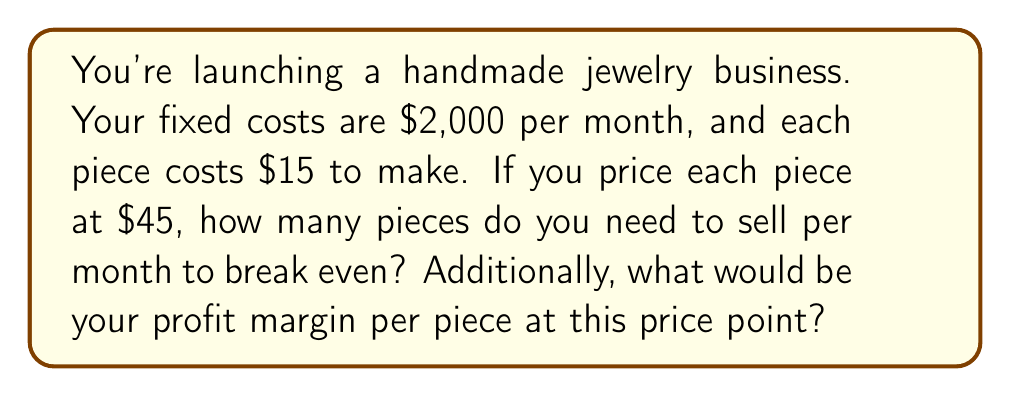What is the answer to this math problem? Let's approach this step-by-step:

1. Break-even point calculation:
   - Fixed costs (FC) = $2,000 per month
   - Variable cost (VC) per piece = $15
   - Selling price (P) per piece = $45

   The break-even point is where total revenue equals total costs:
   $$ \text{Total Revenue} = \text{Total Costs} $$
   $$ P \cdot x = \text{FC} + \text{VC} \cdot x $$
   
   Where x is the number of pieces sold.

   $$ 45x = 2000 + 15x $$
   $$ 30x = 2000 $$
   $$ x = \frac{2000}{30} = 66.67 $$

   Round up to 67 pieces, as you can't sell a fraction of a piece.

2. Profit margin calculation:
   - Revenue per piece = $45
   - Cost per piece = $15
   - Profit per piece = $45 - $15 = $30

   Profit margin = $\frac{\text{Profit}}{\text{Revenue}} \times 100\%$

   $$ \text{Profit Margin} = \frac{30}{45} \times 100\% = 66.67\% $$
Answer: 67 pieces; 66.67% 